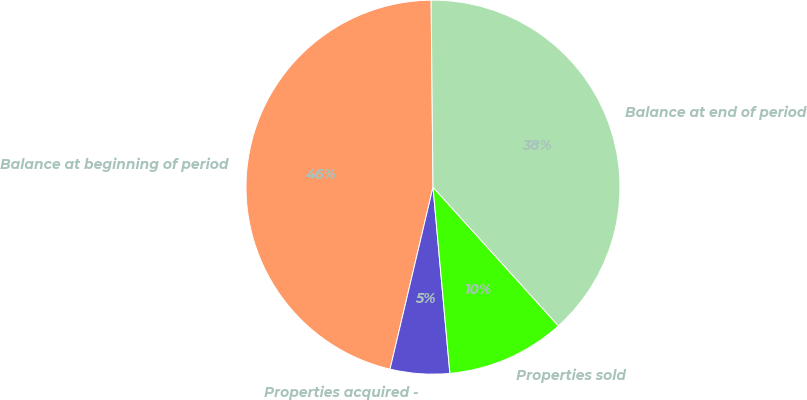<chart> <loc_0><loc_0><loc_500><loc_500><pie_chart><fcel>Balance at beginning of period<fcel>Properties acquired -<fcel>Properties sold<fcel>Balance at end of period<nl><fcel>46.15%<fcel>5.13%<fcel>10.26%<fcel>38.46%<nl></chart> 